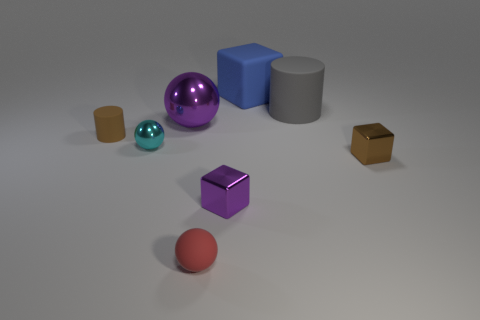Subtract all tiny spheres. How many spheres are left? 1 Add 1 large purple metallic objects. How many objects exist? 9 Subtract all blue spheres. Subtract all green cubes. How many spheres are left? 3 Subtract all cylinders. How many objects are left? 6 Subtract all red matte things. Subtract all large rubber objects. How many objects are left? 5 Add 7 big matte blocks. How many big matte blocks are left? 8 Add 6 big cylinders. How many big cylinders exist? 7 Subtract 1 cyan spheres. How many objects are left? 7 